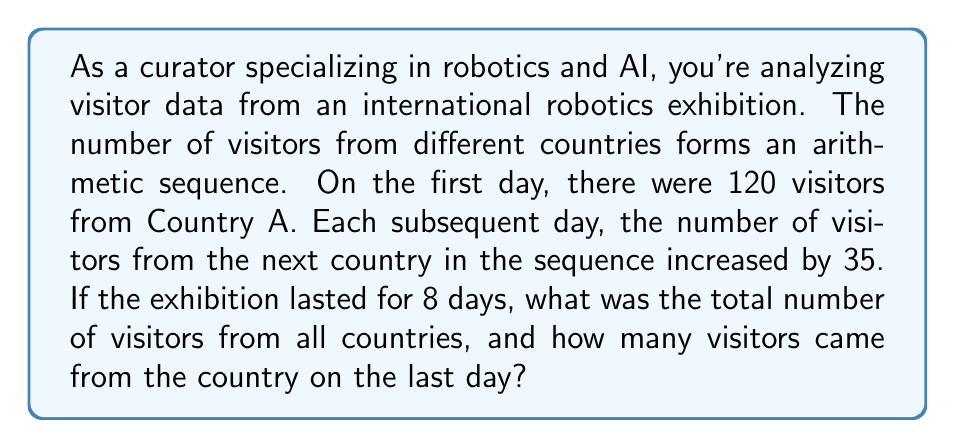Could you help me with this problem? Let's approach this step-by-step using the properties of arithmetic sequences:

1) First, let's identify the components of our arithmetic sequence:
   - $a_1 = 120$ (first term)
   - $d = 35$ (common difference)
   - $n = 8$ (number of terms)

2) To find the last term, we can use the arithmetic sequence formula:
   $a_n = a_1 + (n-1)d$
   $a_8 = 120 + (8-1)35 = 120 + 245 = 365$

3) Now, to find the sum of all terms, we can use the arithmetic series formula:
   $S_n = \frac{n}{2}(a_1 + a_n)$

   Where:
   $S_n$ is the sum of the series
   $n$ is the number of terms
   $a_1$ is the first term
   $a_n$ is the last term

4) Substituting our values:
   $S_8 = \frac{8}{2}(120 + 365) = 4(485) = 1940$

Therefore, the total number of visitors from all countries over the 8 days was 1940, and the number of visitors from the country on the last day was 365.
Answer: Total visitors: 1940
Visitors on the last day: 365 